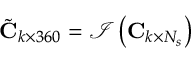<formula> <loc_0><loc_0><loc_500><loc_500>\tilde { C } _ { k \times 3 6 0 } = \mathcal { I } \left ( C _ { k \times N _ { s } } \right )</formula> 